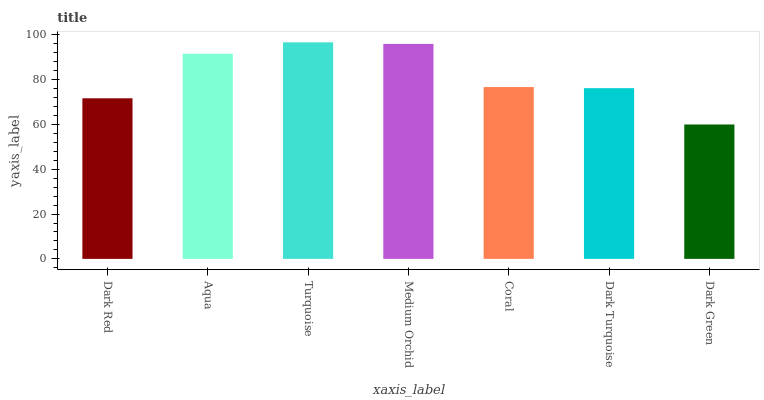Is Dark Green the minimum?
Answer yes or no. Yes. Is Turquoise the maximum?
Answer yes or no. Yes. Is Aqua the minimum?
Answer yes or no. No. Is Aqua the maximum?
Answer yes or no. No. Is Aqua greater than Dark Red?
Answer yes or no. Yes. Is Dark Red less than Aqua?
Answer yes or no. Yes. Is Dark Red greater than Aqua?
Answer yes or no. No. Is Aqua less than Dark Red?
Answer yes or no. No. Is Coral the high median?
Answer yes or no. Yes. Is Coral the low median?
Answer yes or no. Yes. Is Dark Red the high median?
Answer yes or no. No. Is Medium Orchid the low median?
Answer yes or no. No. 